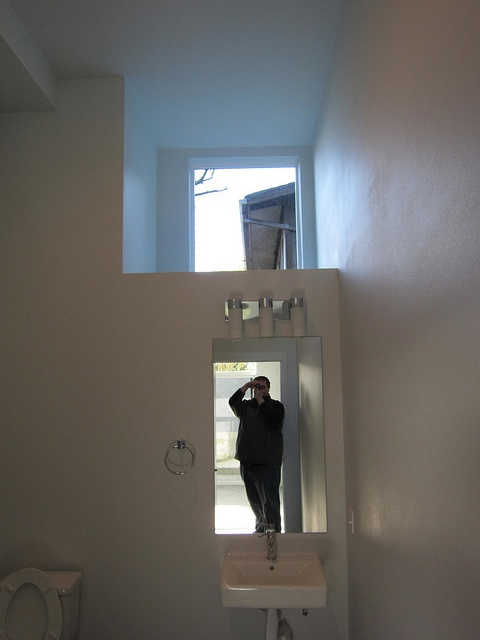Describe the objects in this image and their specific colors. I can see people in gray, black, ivory, and darkgray tones, sink in gray and black tones, and toilet in gray and black tones in this image. 